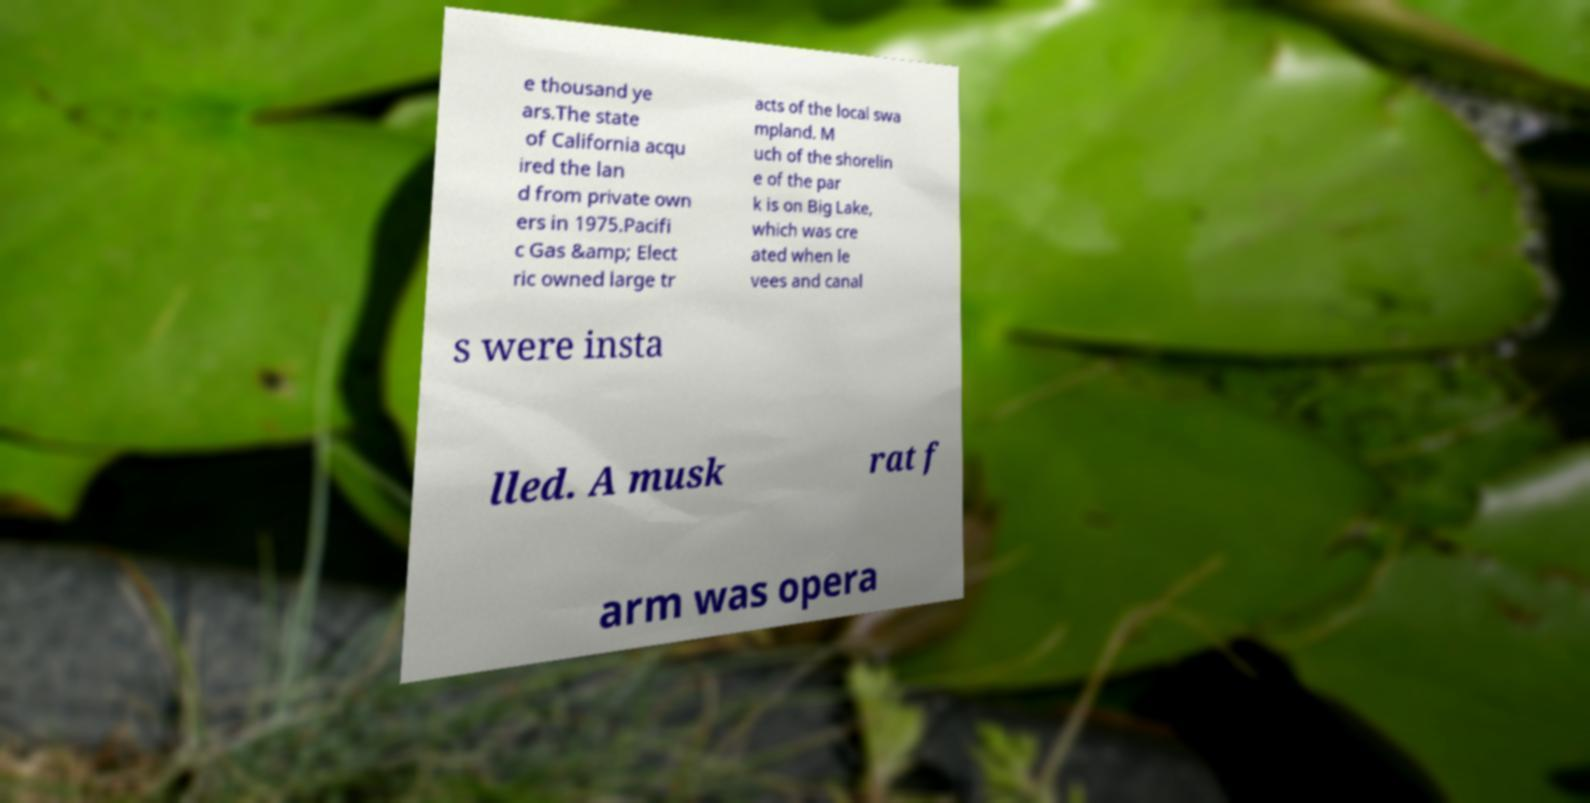Please identify and transcribe the text found in this image. e thousand ye ars.The state of California acqu ired the lan d from private own ers in 1975.Pacifi c Gas &amp; Elect ric owned large tr acts of the local swa mpland. M uch of the shorelin e of the par k is on Big Lake, which was cre ated when le vees and canal s were insta lled. A musk rat f arm was opera 